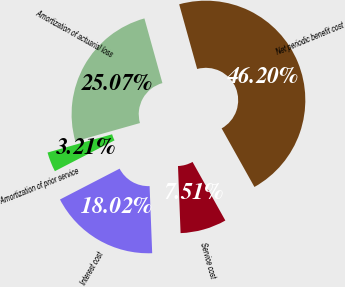<chart> <loc_0><loc_0><loc_500><loc_500><pie_chart><fcel>Service cost<fcel>Interest cost<fcel>Amortization of prior service<fcel>Amortization of actuarial loss<fcel>Net periodic benefit cost<nl><fcel>7.51%<fcel>18.02%<fcel>3.21%<fcel>25.07%<fcel>46.2%<nl></chart> 